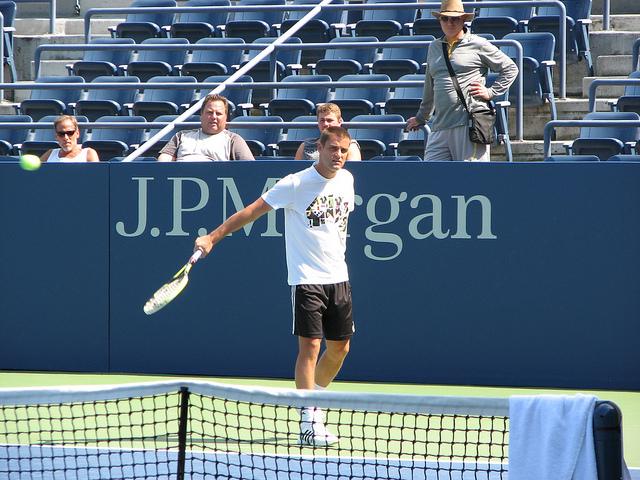What sport is this?
Keep it brief. Tennis. Is a professional game being played?
Be succinct. Yes. What is the doing in the picture?
Answer briefly. Playing tennis. 